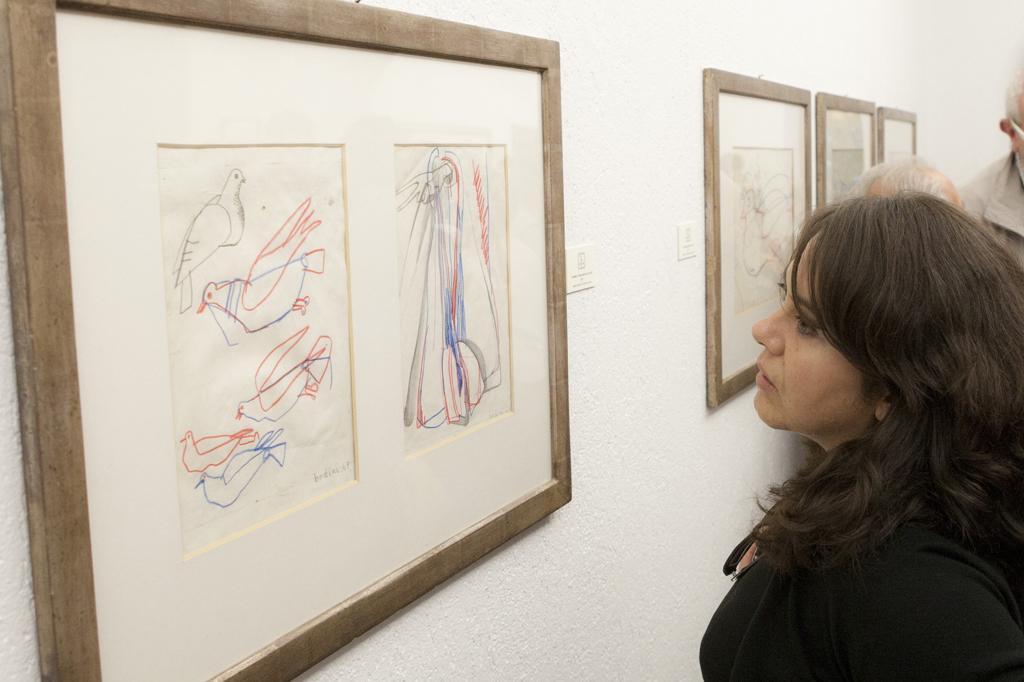In one or two sentences, can you explain what this image depicts? In this picture there are people and we can see frames on the wall. 